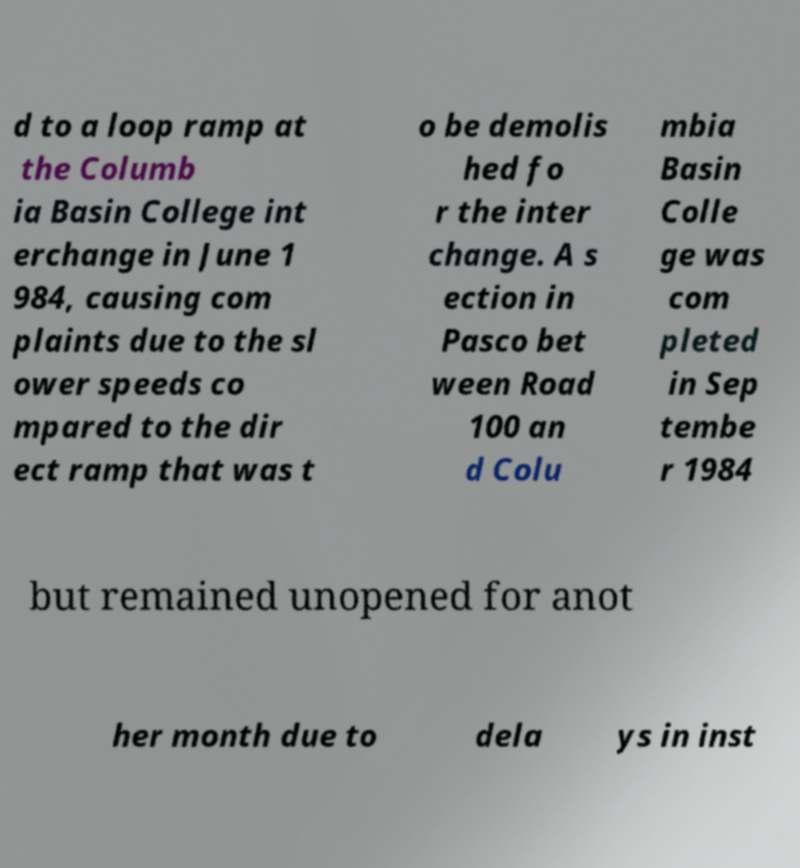Please read and relay the text visible in this image. What does it say? d to a loop ramp at the Columb ia Basin College int erchange in June 1 984, causing com plaints due to the sl ower speeds co mpared to the dir ect ramp that was t o be demolis hed fo r the inter change. A s ection in Pasco bet ween Road 100 an d Colu mbia Basin Colle ge was com pleted in Sep tembe r 1984 but remained unopened for anot her month due to dela ys in inst 